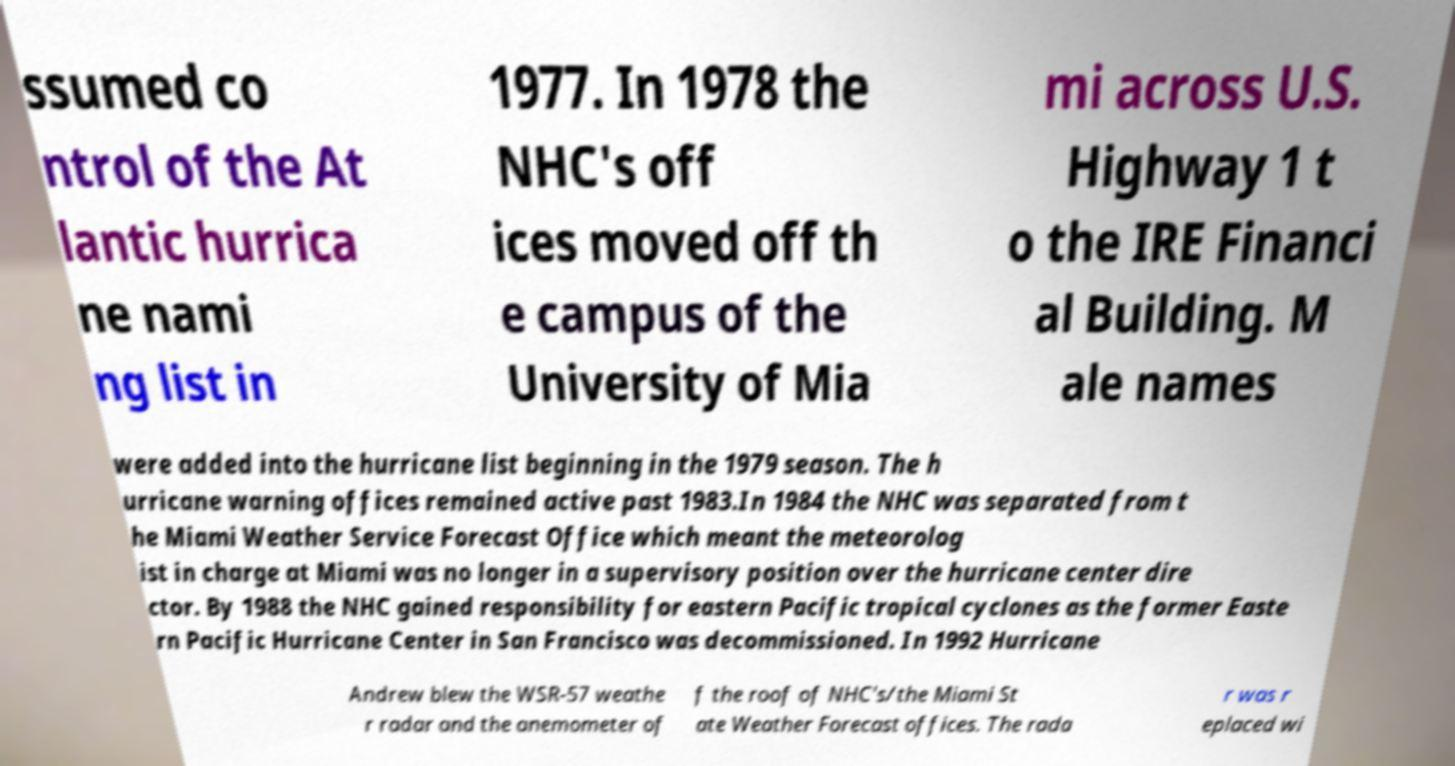Could you extract and type out the text from this image? ssumed co ntrol of the At lantic hurrica ne nami ng list in 1977. In 1978 the NHC's off ices moved off th e campus of the University of Mia mi across U.S. Highway 1 t o the IRE Financi al Building. M ale names were added into the hurricane list beginning in the 1979 season. The h urricane warning offices remained active past 1983.In 1984 the NHC was separated from t he Miami Weather Service Forecast Office which meant the meteorolog ist in charge at Miami was no longer in a supervisory position over the hurricane center dire ctor. By 1988 the NHC gained responsibility for eastern Pacific tropical cyclones as the former Easte rn Pacific Hurricane Center in San Francisco was decommissioned. In 1992 Hurricane Andrew blew the WSR-57 weathe r radar and the anemometer of f the roof of NHC's/the Miami St ate Weather Forecast offices. The rada r was r eplaced wi 